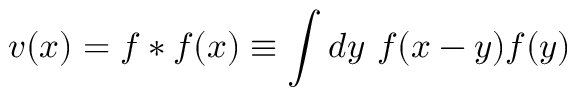Convert formula to latex. <formula><loc_0><loc_0><loc_500><loc_500>v ( x ) = f \ast f ( x ) \equiv \int d y \ f ( x - y ) f ( y )</formula> 